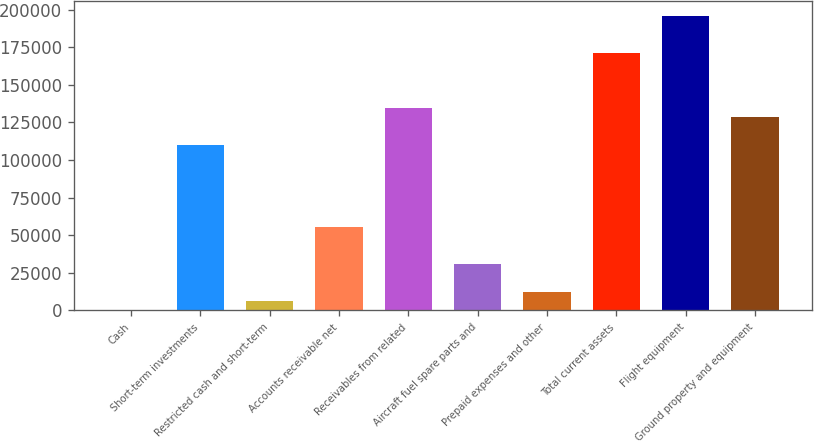<chart> <loc_0><loc_0><loc_500><loc_500><bar_chart><fcel>Cash<fcel>Short-term investments<fcel>Restricted cash and short-term<fcel>Accounts receivable net<fcel>Receivables from related<fcel>Aircraft fuel spare parts and<fcel>Prepaid expenses and other<fcel>Total current assets<fcel>Flight equipment<fcel>Ground property and equipment<nl><fcel>287<fcel>110292<fcel>6398.4<fcel>55289.6<fcel>134738<fcel>30844<fcel>12509.8<fcel>171406<fcel>195852<fcel>128626<nl></chart> 